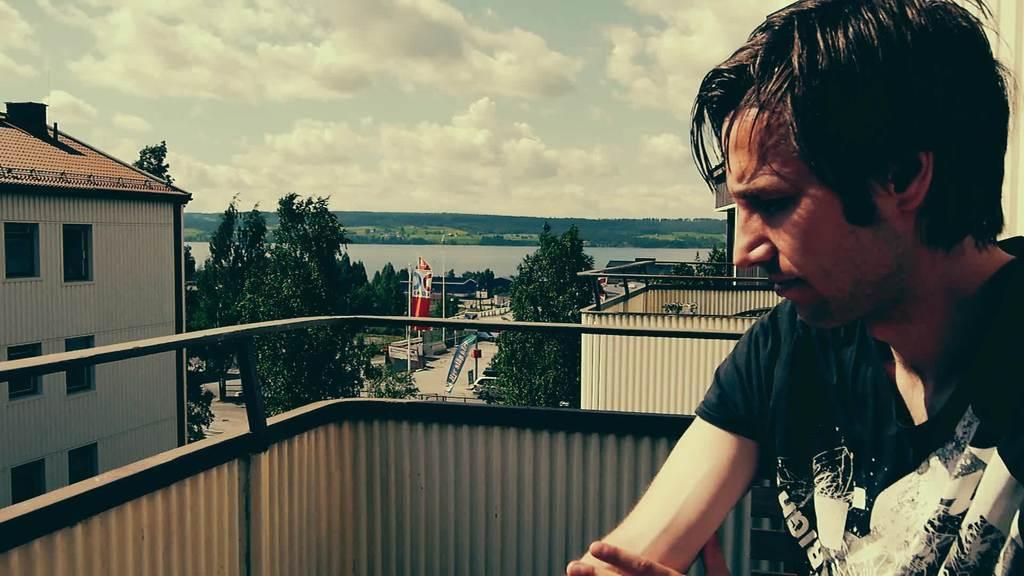How would you summarize this image in a sentence or two? On the right there is a man who is wearing t-shirt. He is sitting near to the fencing. On the left there is a building. In the background we can see street lights, banners, posters, trees and roads. Here we can see mountains and water. On the top we can see sky and clouds. 